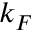Convert formula to latex. <formula><loc_0><loc_0><loc_500><loc_500>k _ { F }</formula> 